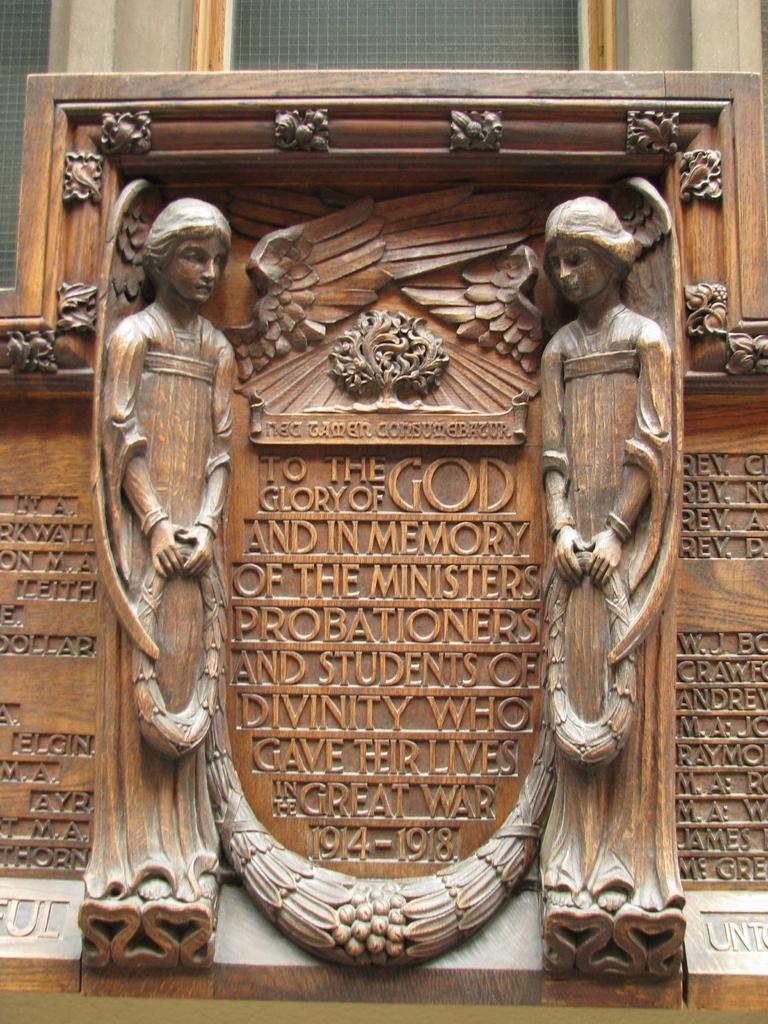Could you give a brief overview of what you see in this image? In the center of the image we can see sculptures made of wood. In the background we can see windows and a wall. 